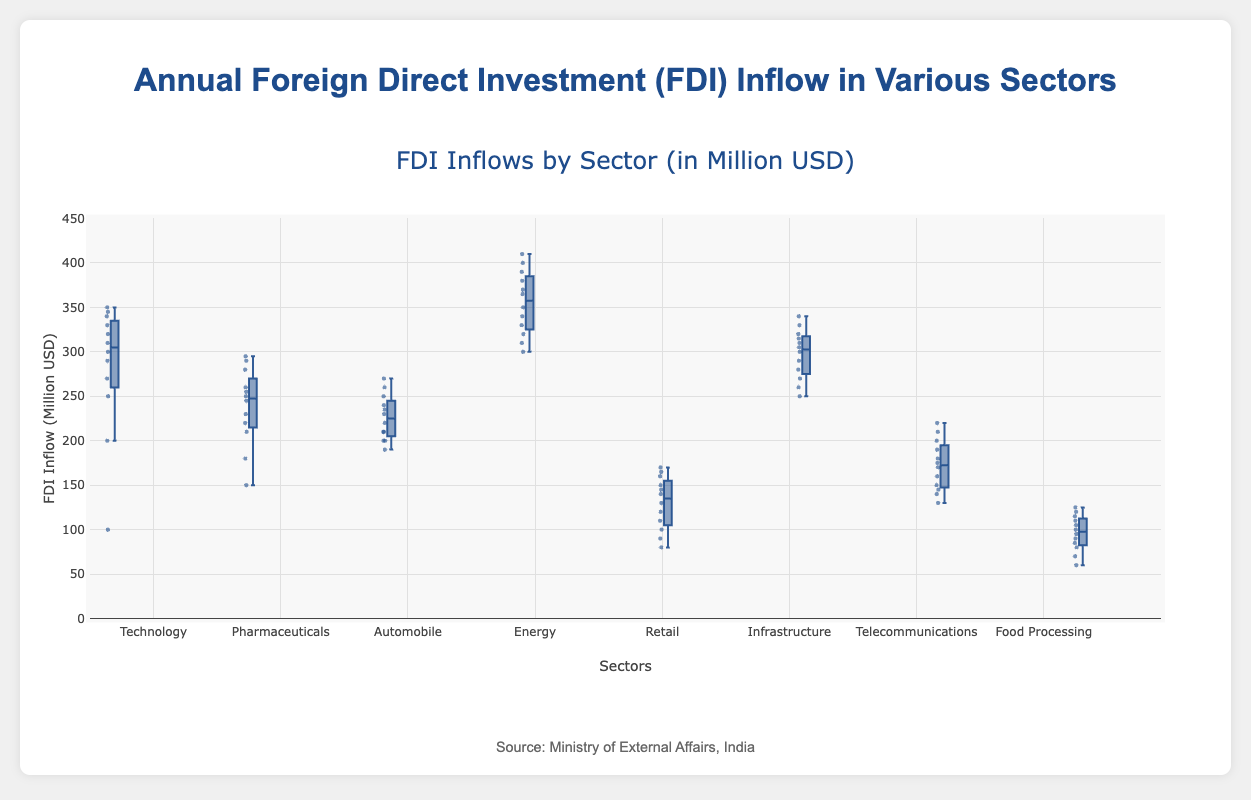What is the title of the figure? The title is usually displayed at the top of the figure. It provides a summary of what the figure represents. The title in this case is prominently mentioned in the code.
Answer: Annual Foreign Direct Investment (FDI) Inflow in Various Sectors Which sector has the highest median FDI inflow? The median value of each sector is displayed as the central line inside the box of each box plot. The sector with the highest central line has the highest median FDI inflow. For this data, Energy has the highest median value.
Answer: Energy What is the difference between the median FDI inflow of the Technology sector and the Retail sector? The median value of Technology can be found by looking for the central line inside its box, which is around 305 million USD. The median value of Retail is around 130 million USD. The difference is then calculated as 305 - 130.
Answer: 175 million USD Identify any sector with an FDI inflow outlier. Outliers in a box plot are typically represented as points outside the whiskers. By observing the plot, one can note which sectors have these outlying points. In this case, the Food Processing sector has outlying points.
Answer: Food Processing What is the approximate range of the FDI inflow in the Automobile sector? The range in a box plot is shown by the distance from the minimum whisker to the maximum whisker. The lowest whisker for Automobile is around 190 million USD and the highest is around 270 million USD. The range is then 270 - 190.
Answer: 80 million USD Which sector has the smallest interquartile range (IQR) of FDI inflow? The IQR is represented by the height of the box in the box plot, which measures the range between the first quartile (lower boundary of the box) and the third quartile (upper boundary of the box). By comparing the heights of the boxes, you can determine that Retail has the smallest IQR.
Answer: Retail How does the median value of Telecommunications compare to that of Pharmaceuticals? To compare the medians, observe the central lines inside the boxes for Telecommunications (around 160 million USD) and Pharmaceuticals (around 240 million USD). Telecommunications has a lower median FDI inflow compared to Pharmaceuticals.
Answer: Lower Which sector has the highest maximum FDI inflow? The maximum value is represented by the top whisker in each box plot. By comparing the top whiskers, Energy stands out with a maximum close to 410 million USD.
Answer: Energy What is the typical spread (interquartile range) of FDI inflow in the Infrastructure sector compared to Food Processing? The IQR can be calculated for both sectors. For Infrastructure, the IQR is from about 270 million USD to 320 million USD (IQR = 320 - 270 = 50). For Food Processing, the IQR is from about 90 million USD to 110 million USD (IQR = 110 - 90 = 20). Comparing these, Infrastructure has a larger IQR.
Answer: Infrastructure has a larger IQR 